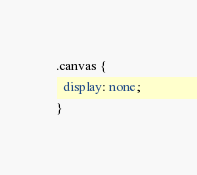Convert code to text. <code><loc_0><loc_0><loc_500><loc_500><_CSS_>.canvas {
  display: none;
}
</code> 